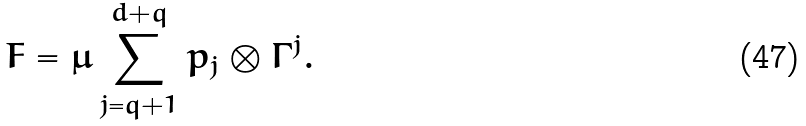<formula> <loc_0><loc_0><loc_500><loc_500>F = \mu \sum _ { j = q + 1 } ^ { d + q } p _ { j } \otimes \Gamma ^ { j } .</formula> 